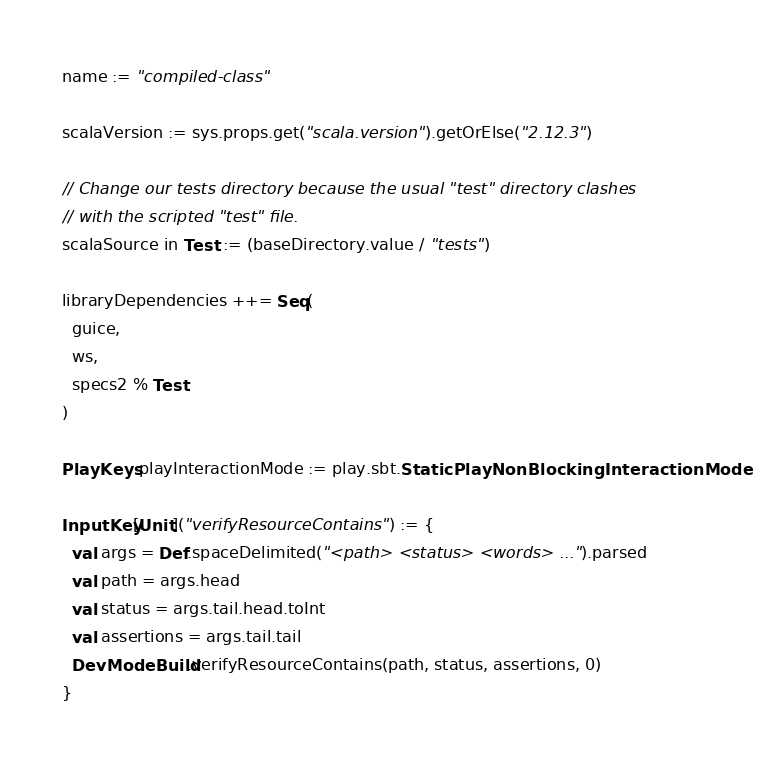<code> <loc_0><loc_0><loc_500><loc_500><_Scala_>name := "compiled-class"

scalaVersion := sys.props.get("scala.version").getOrElse("2.12.3")

// Change our tests directory because the usual "test" directory clashes
// with the scripted "test" file.
scalaSource in Test := (baseDirectory.value / "tests")

libraryDependencies ++= Seq(
  guice,
  ws,
  specs2 % Test
)

PlayKeys.playInteractionMode := play.sbt.StaticPlayNonBlockingInteractionMode

InputKey[Unit]("verifyResourceContains") := {
  val args = Def.spaceDelimited("<path> <status> <words> ...").parsed
  val path = args.head
  val status = args.tail.head.toInt
  val assertions = args.tail.tail
  DevModeBuild.verifyResourceContains(path, status, assertions, 0)
}
</code> 